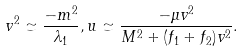<formula> <loc_0><loc_0><loc_500><loc_500>v ^ { 2 } \simeq \frac { - m ^ { 2 } } { \lambda _ { 1 } } , u \simeq \frac { - \mu v ^ { 2 } } { M ^ { 2 } + ( f _ { 1 } + f _ { 2 } ) v ^ { 2 } } .</formula> 